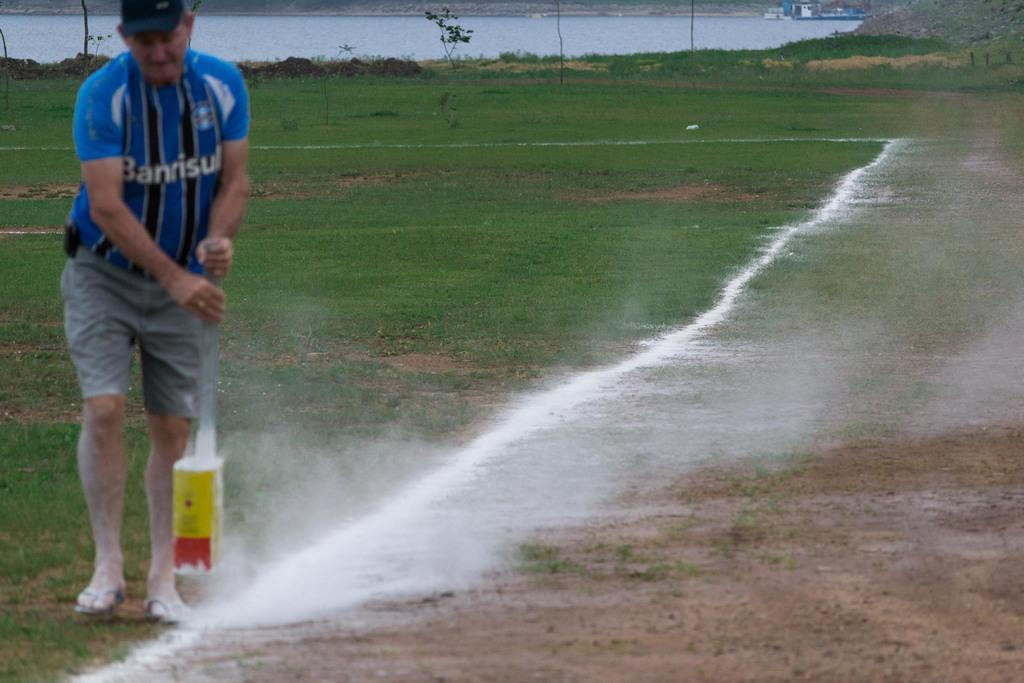<image>
Present a compact description of the photo's key features. A man in a Banrisul shirt paints lines on a sports field. 